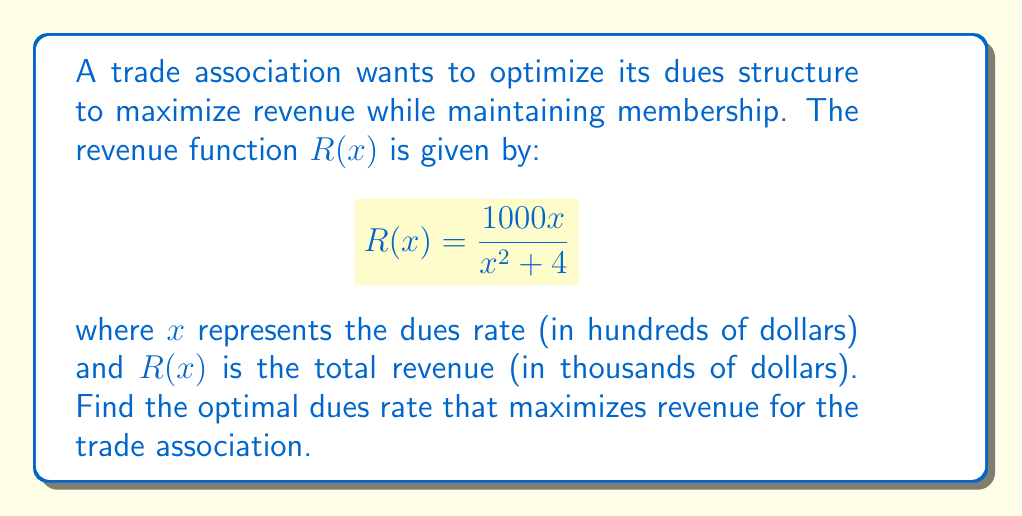What is the answer to this math problem? To find the optimal dues rate, we need to maximize the revenue function $R(x)$. This can be done by finding the critical points of the function and determining which one yields the maximum value.

1) First, let's find the derivative of $R(x)$ using the quotient rule:

   $$R'(x) = \frac{(1000)(x^2 + 4) - 1000x(2x)}{(x^2 + 4)^2}$$

2) Simplify:

   $$R'(x) = \frac{1000(x^2 + 4) - 2000x^2}{(x^2 + 4)^2} = \frac{1000(4 - x^2)}{(x^2 + 4)^2}$$

3) Set $R'(x) = 0$ and solve for $x$:

   $$\frac{1000(4 - x^2)}{(x^2 + 4)^2} = 0$$

   $4 - x^2 = 0$
   $x^2 = 4$
   $x = \pm 2$

4) Since dues rates can't be negative, we only consider $x = 2$.

5) To confirm this is a maximum, we can check the second derivative or observe that $R'(x)$ is positive for $x < 2$ and negative for $x > 2$.

6) Therefore, the optimal dues rate is 2 hundred dollars, or $200.

7) We can calculate the maximum revenue:

   $$R(2) = \frac{1000(2)}{2^2 + 4} = \frac{2000}{8} = 250$$

Thus, the maximum revenue is $250,000.
Answer: $200 dues rate; $250,000 maximum revenue 